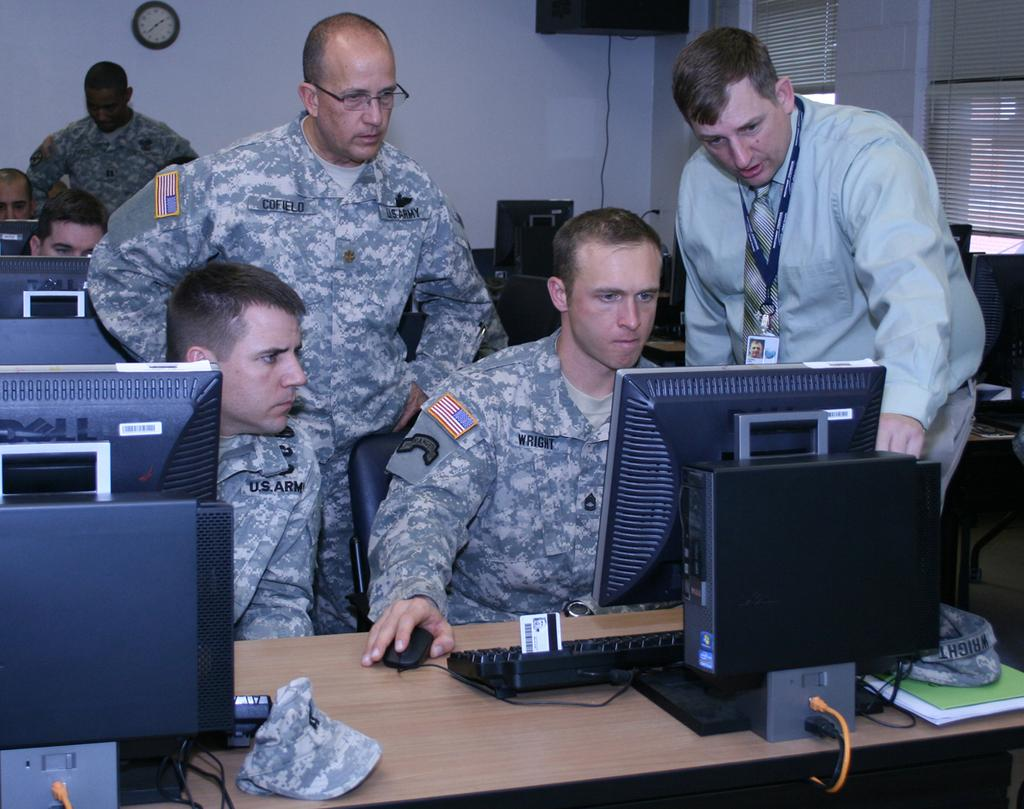Provide a one-sentence caption for the provided image. Four army men are looking at a computer and the nearest has Wright printed on his uniform. 